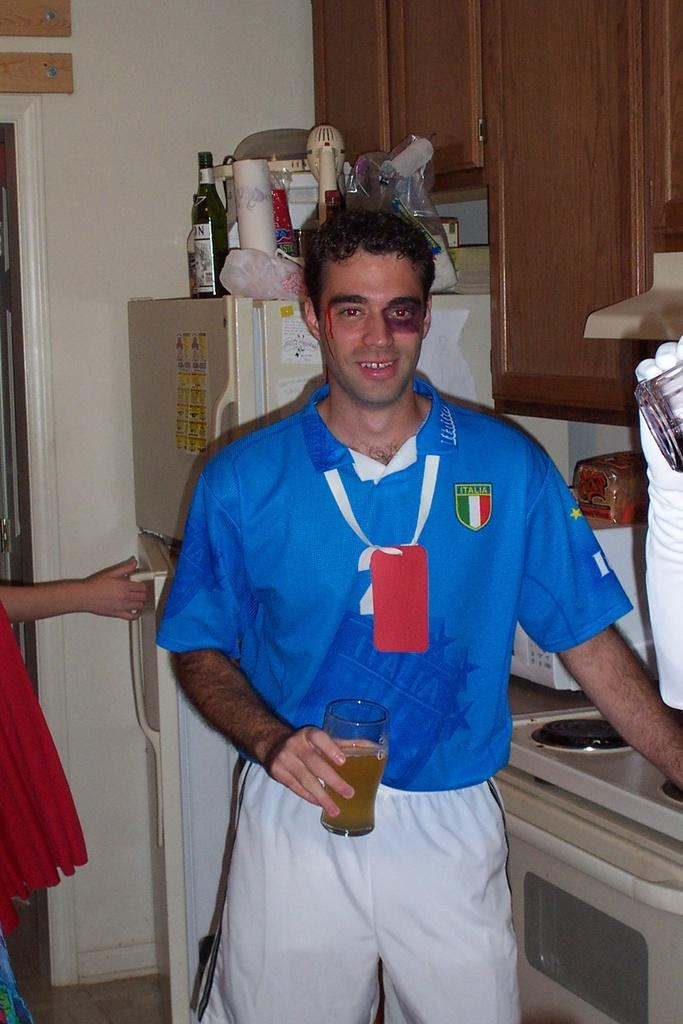<image>
Describe the image concisely. A man wearing an Italia jersey has a black eye. 